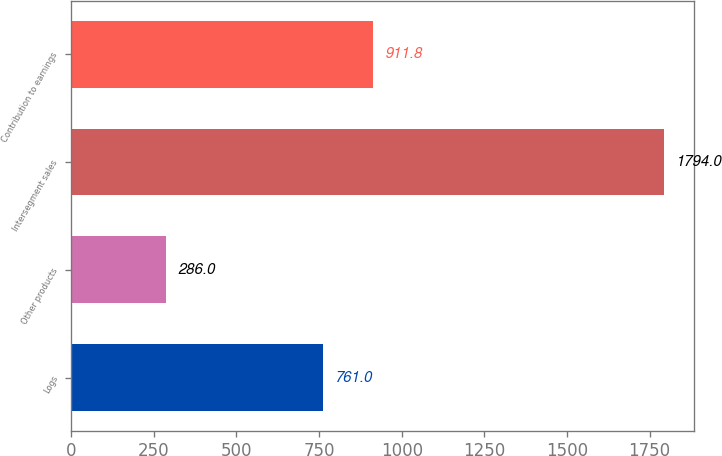Convert chart to OTSL. <chart><loc_0><loc_0><loc_500><loc_500><bar_chart><fcel>Logs<fcel>Other products<fcel>Intersegment sales<fcel>Contribution to earnings<nl><fcel>761<fcel>286<fcel>1794<fcel>911.8<nl></chart> 